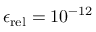<formula> <loc_0><loc_0><loc_500><loc_500>\epsilon _ { r e l } = 1 0 ^ { - 1 2 }</formula> 